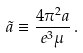<formula> <loc_0><loc_0><loc_500><loc_500>\tilde { a } \equiv \frac { 4 \pi ^ { 2 } a } { e ^ { 3 } \mu } \, .</formula> 